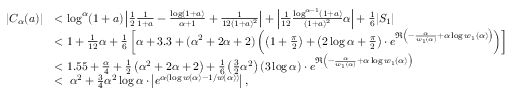<formula> <loc_0><loc_0><loc_500><loc_500>\begin{array} { r l } { | C _ { \alpha } ( a ) | } & { < \log ^ { \alpha } ( 1 + a ) \left | \frac { 1 } { 2 } \frac { 1 } { 1 + a } - \frac { \log ( 1 + a ) } { \alpha + 1 } + \frac { 1 } { 1 2 ( 1 + a ) ^ { 2 } } \right | + \left | \frac { 1 } { 1 2 } \frac { \log ^ { \alpha - 1 } ( 1 + a ) } { ( 1 + a ) ^ { 2 } } \alpha \right | + \frac { 1 } { 6 } | S _ { 1 } | } \\ & { < 1 + \frac { 1 } { 1 2 } \alpha + \frac { 1 } { 6 } \left [ \alpha + 3 . 3 + ( \alpha ^ { 2 } + 2 \alpha + 2 ) \left ( \left ( 1 + \frac { \pi } { 2 } \right ) + \left ( 2 \log \alpha + \frac { \pi } { 2 } \right ) \cdot e ^ { \Re \left ( - \frac { \alpha } { w _ { 1 } ( \alpha ) } + \alpha \log w _ { 1 } ( \alpha ) \right ) } \right ) \right ] } \\ & { < 1 . 5 5 + \frac { \alpha } { 4 } + \frac { 1 } { 2 } \left ( \alpha ^ { 2 } + 2 \alpha + 2 \right ) + \frac { 1 } { 6 } \left ( \frac { 3 } { 2 } \alpha ^ { 2 } \right ) ( 3 \log \alpha ) \cdot e ^ { \Re \left ( - \frac { \alpha } { w _ { 1 } ( \alpha ) } + \alpha \log w _ { 1 } ( \alpha ) \right ) } } \\ & { < \, \alpha ^ { 2 } + \frac { 3 } { 4 } \alpha ^ { 2 } \log \alpha \cdot \left | e ^ { \alpha ( \log w ( \alpha ) - 1 / w ( \alpha ) ) } \right | , } \end{array}</formula> 